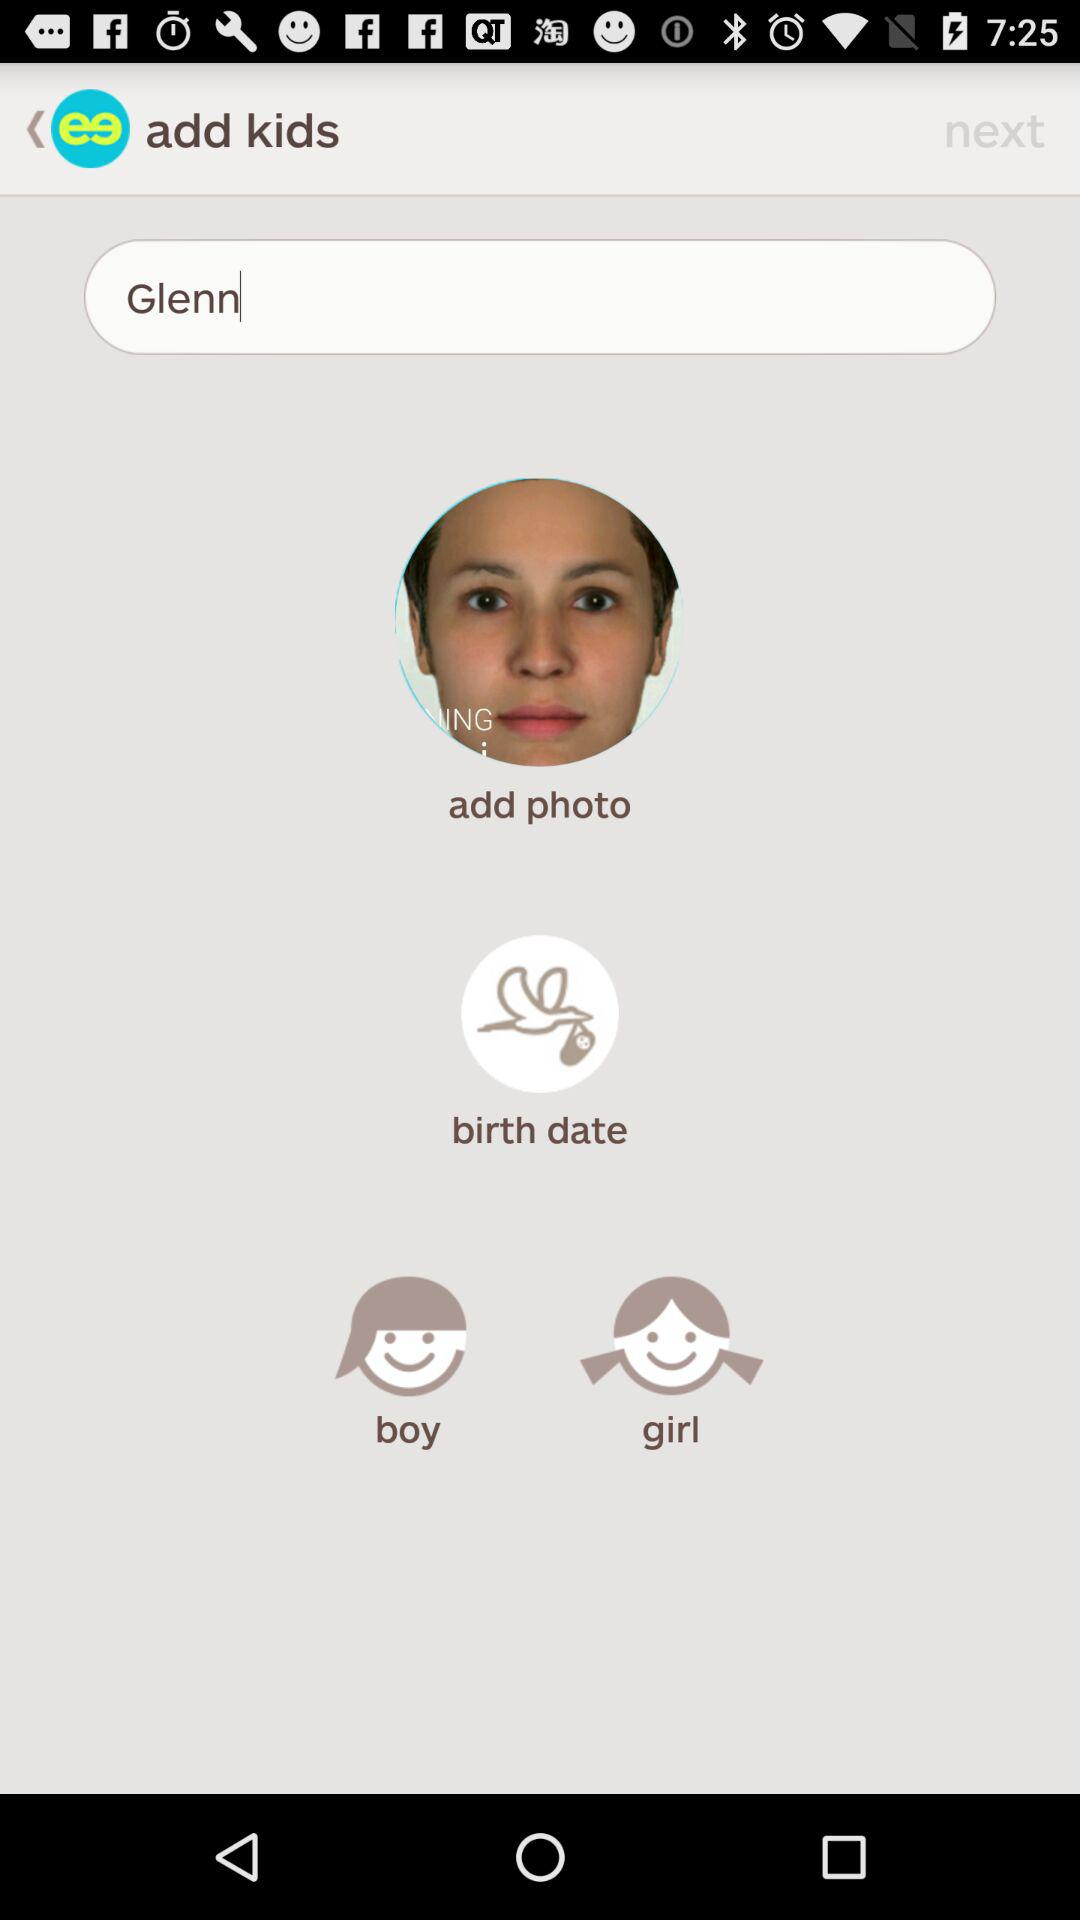What is the name? The name is Glenn. 